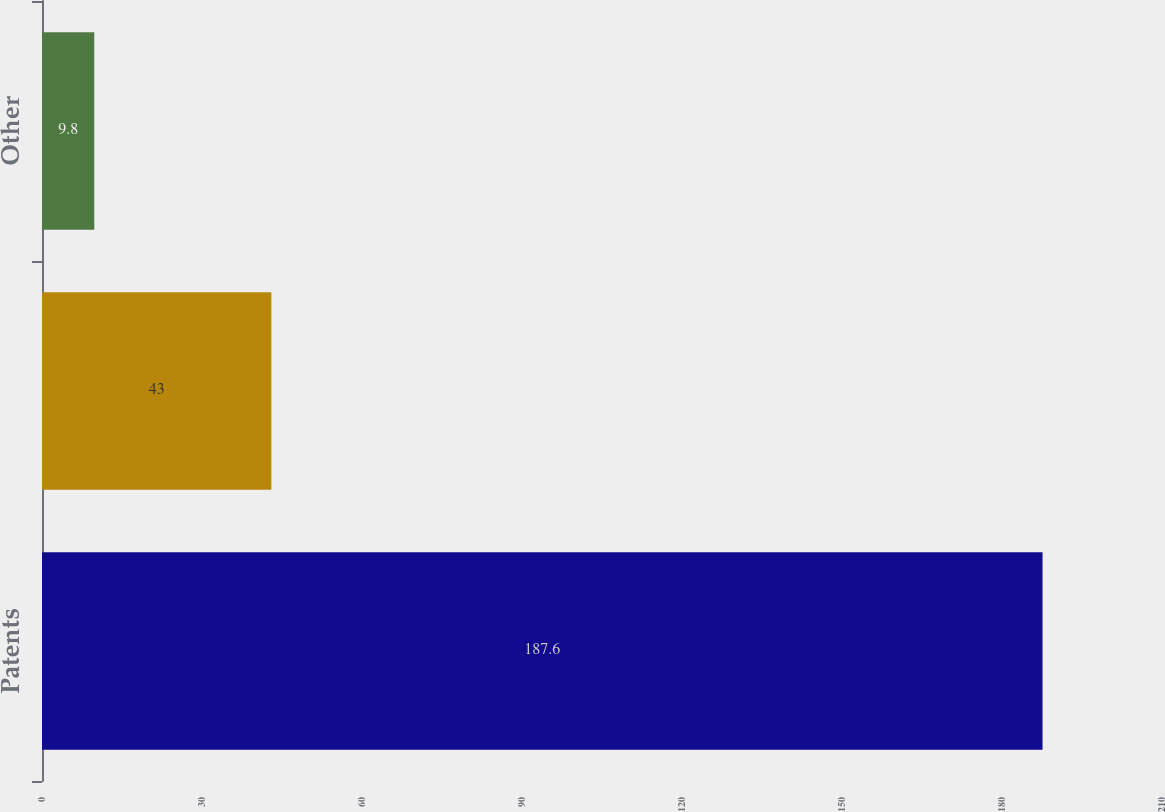Convert chart. <chart><loc_0><loc_0><loc_500><loc_500><bar_chart><fcel>Patents<fcel>Developed technology<fcel>Other<nl><fcel>187.6<fcel>43<fcel>9.8<nl></chart> 